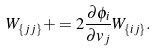<formula> <loc_0><loc_0><loc_500><loc_500>W _ { \{ j j \} } & + = 2 \frac { \partial \phi _ { i } } { \partial v _ { j } } W _ { \{ i j \} } .</formula> 